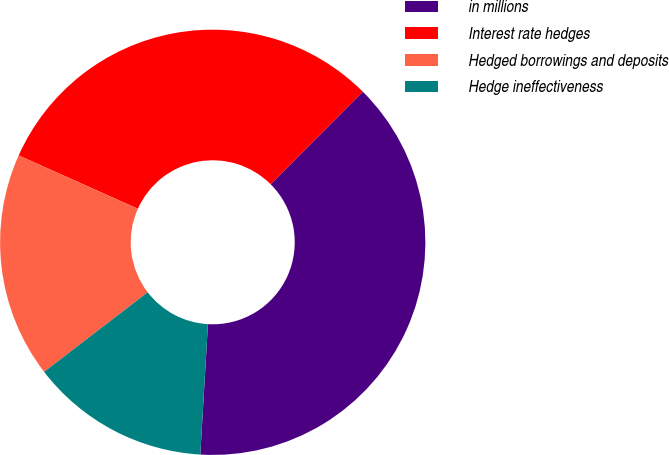Convert chart. <chart><loc_0><loc_0><loc_500><loc_500><pie_chart><fcel>in millions<fcel>Interest rate hedges<fcel>Hedged borrowings and deposits<fcel>Hedge ineffectiveness<nl><fcel>38.45%<fcel>30.78%<fcel>17.13%<fcel>13.64%<nl></chart> 